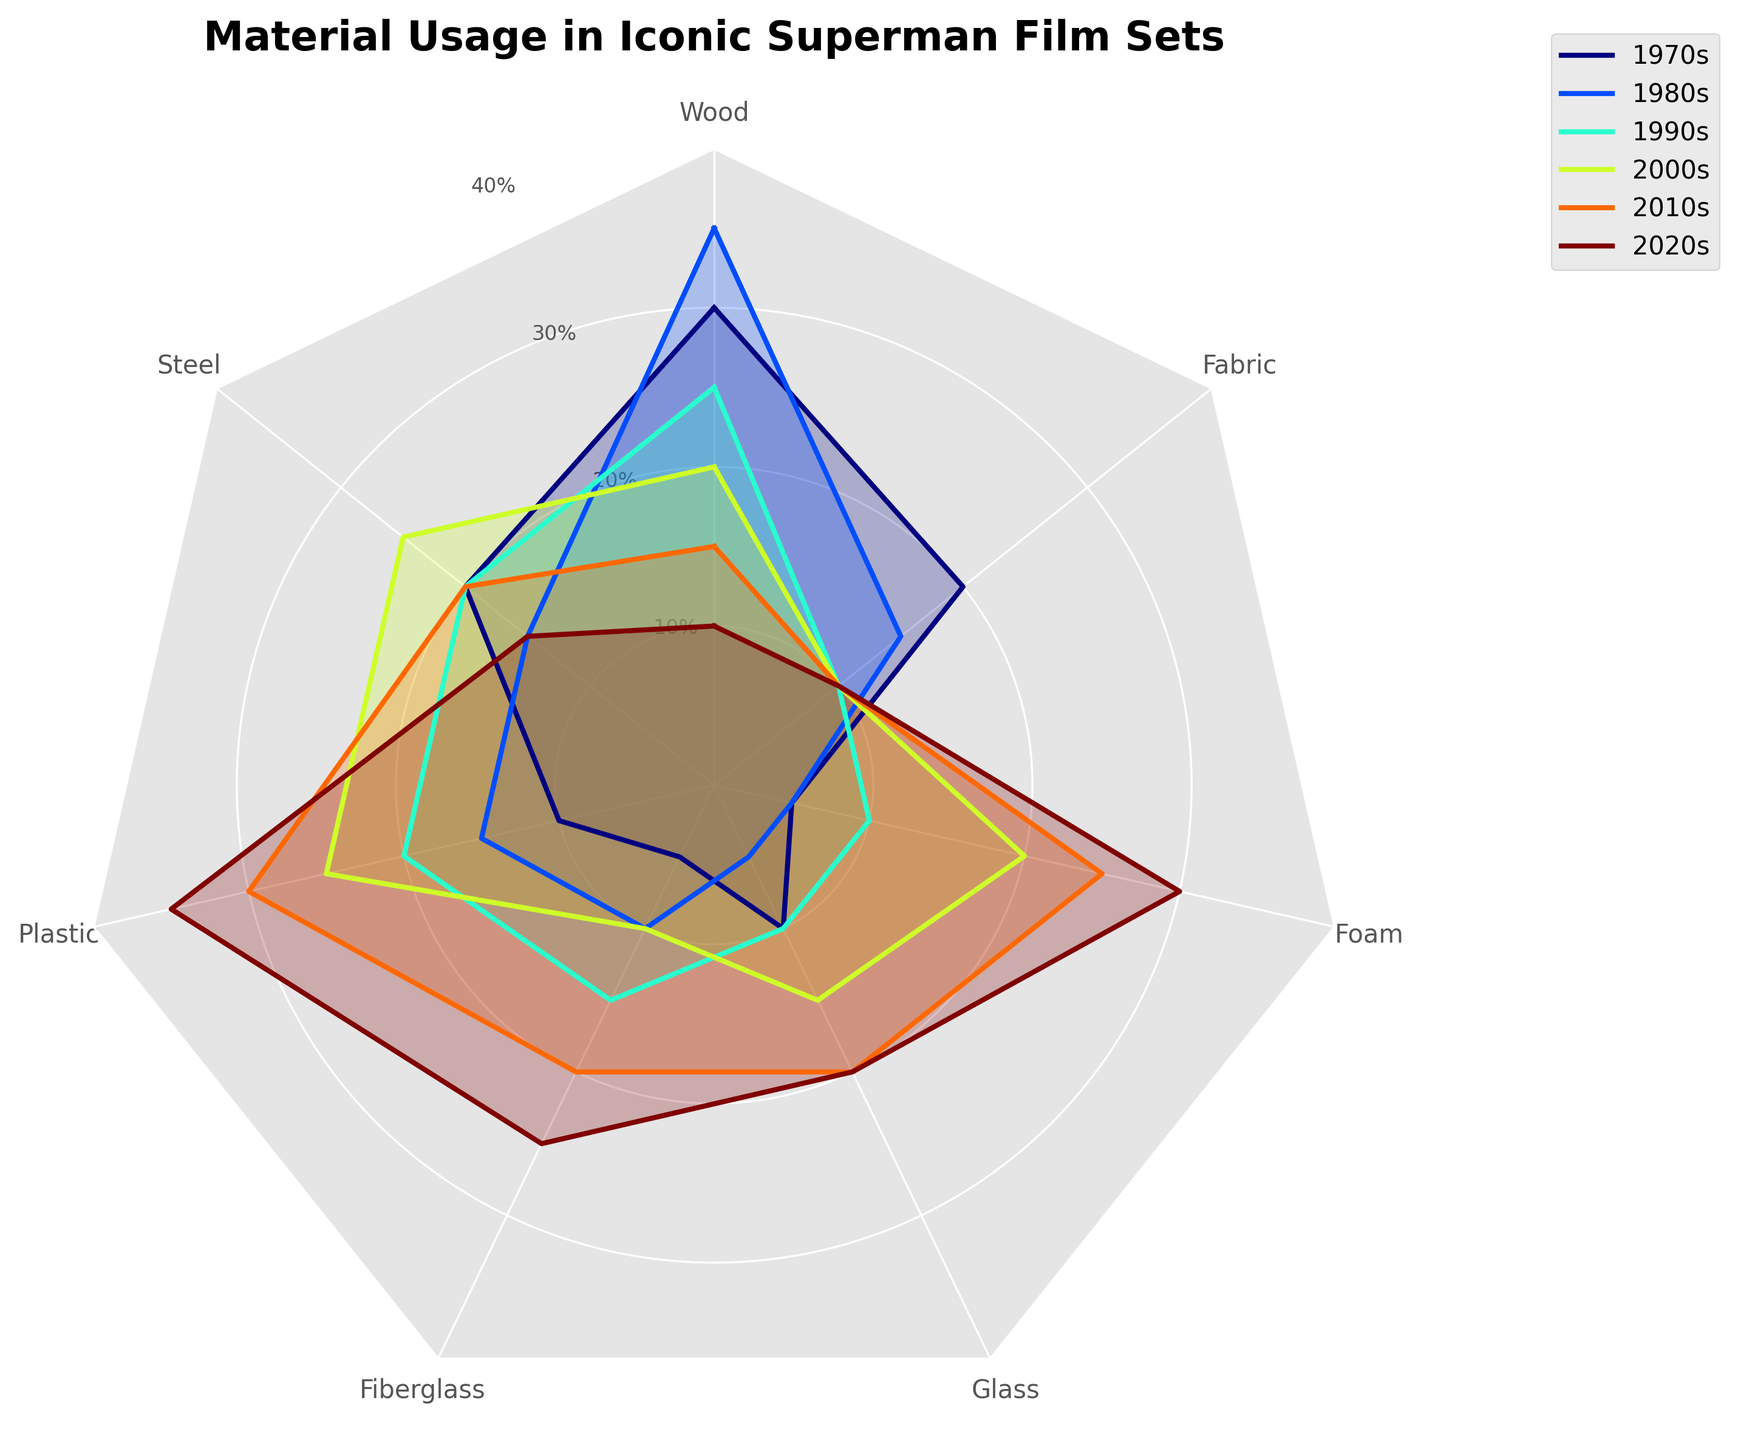What's the title of the figure? The title is located at the top of the figure and is generally larger and bolder than other text elements. For this figure, it reads "Material Usage in Iconic Superman Film Sets".
Answer: Material Usage in Iconic Superman Film Sets How many different materials are depicted in the radar chart? Each vertex on the radar chart represents a different material. Counting these vertices gives the total number of materials.
Answer: 7 Which material had the highest usage in the 1970s? Looking at the 1970s curve on the radar chart, the material with the highest value is where the line extends farthest from the center in this decade's color.
Answer: Wood What are the three most used materials in the 2020s? The three materials with the largest extension from the center in the 2020s color indicate the highest usage.
Answer: Plastic, Foam, Fiberglass How did the usage of plastic change from the 1970s to the 2020s? Comparing the values for plastic at the vertices for the 1970s and the 2020s, you can see if the line extends further or closer to the center.
Answer: Increased What material had consistent usage of 10% from the 1990s to the 2020s? Checking the positions of all materials in the 1990s, 2000s, 2010s, and 2020s curves for a consistent extension that matches 10% usage.
Answer: Fabric Which decade had the most varied material usage, indicated by the largest spread in the radar chart? The spread of a decade's curve can be judged by seeing which one has the most variation in distances from the center among materials.
Answer: 2020s Which material saw the greatest increase in usage over time? Measuring the difference between the usage values over the decades for each material will determine the greatest change.
Answer: Plastic By how much did the usage of glass change from the 1980s to the 2000s? Subtract the 1980s value for glass from its 2000s value, checking their positions in the respective decades' outlines.
Answer: 15% (from 5% to 20%) What material had a decrease in usage every decade from the 1970s to the 2020s? Trace the radar chart to find any material whose usage consistently diminished over each decade.
Answer: Wood 